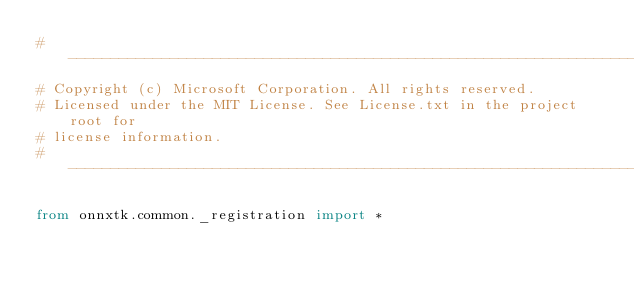<code> <loc_0><loc_0><loc_500><loc_500><_Python_># -------------------------------------------------------------------------
# Copyright (c) Microsoft Corporation. All rights reserved.
# Licensed under the MIT License. See License.txt in the project root for
# license information.
# --------------------------------------------------------------------------

from onnxtk.common._registration import *
</code> 